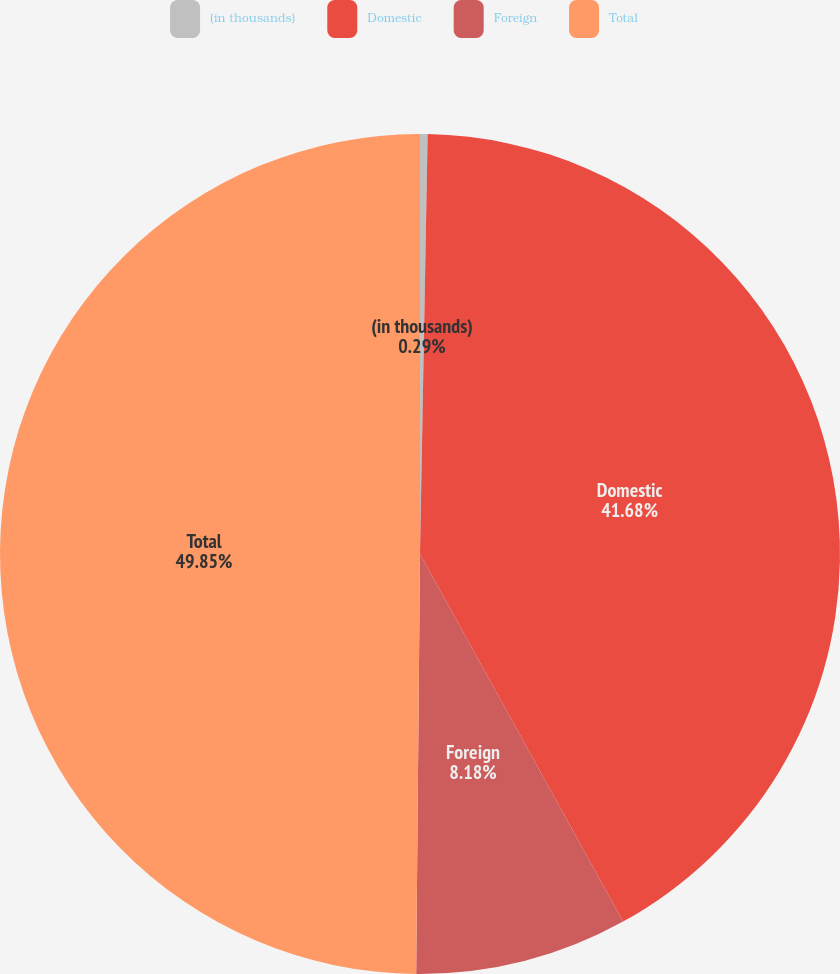Convert chart to OTSL. <chart><loc_0><loc_0><loc_500><loc_500><pie_chart><fcel>(in thousands)<fcel>Domestic<fcel>Foreign<fcel>Total<nl><fcel>0.29%<fcel>41.68%<fcel>8.18%<fcel>49.86%<nl></chart> 